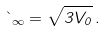<formula> <loc_0><loc_0><loc_500><loc_500>\theta _ { \infty } = \sqrt { 3 V _ { 0 } } \, .</formula> 